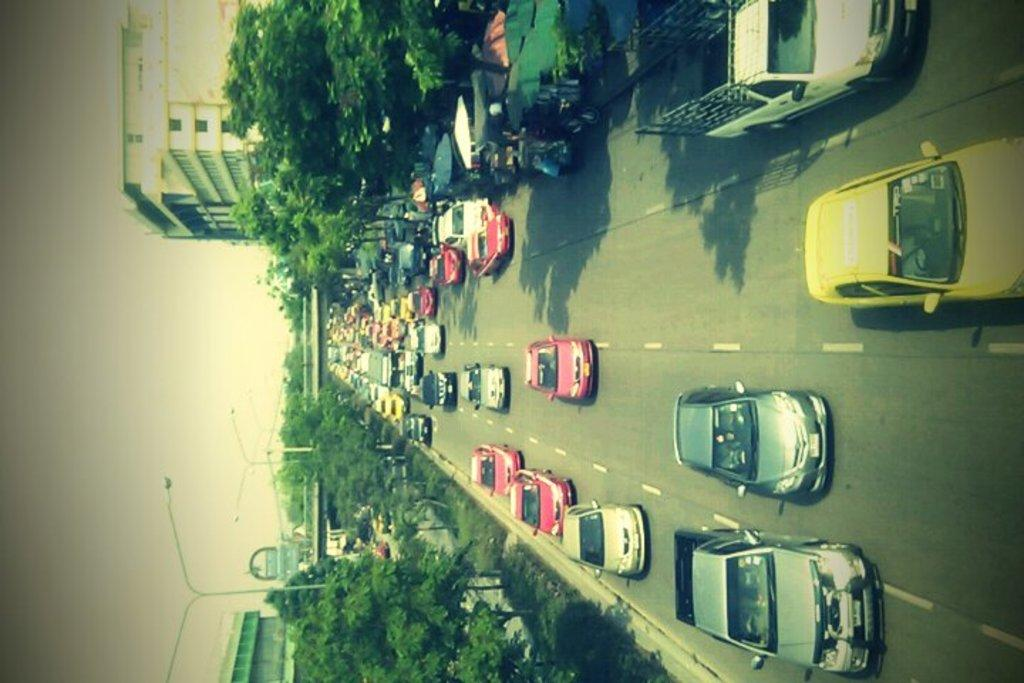What can be seen in the center of the image? There are cars on the road in the center of the image. What type of structures are present in the image? There are buildings in the image. What natural elements can be seen in the image? There are trees in the image. Can you describe the poles in the image? There are poles at the top and bottom side of the image. Where is the library located in the image? There is no library present in the image. Can you describe the beast that is attacking the cars in the image? There is no beast present in the image; the cars are simply driving on the road. 